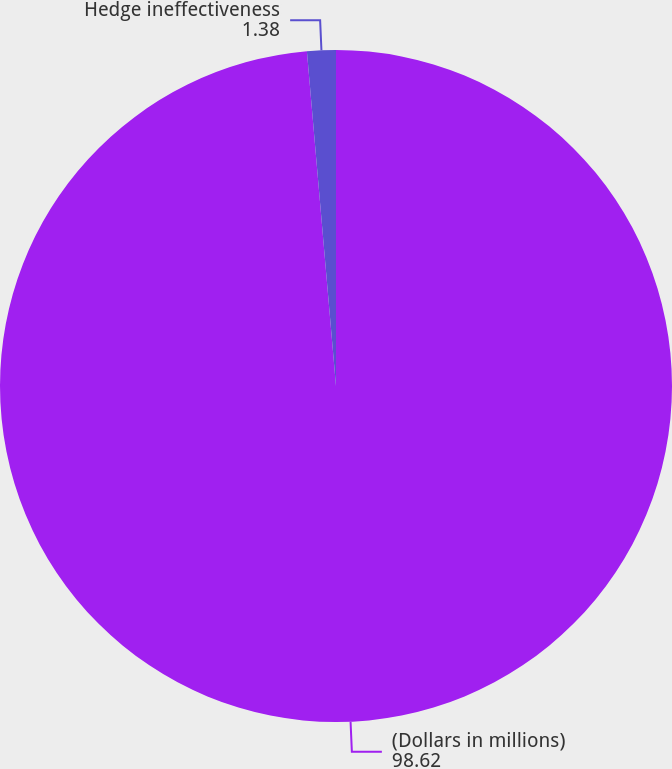<chart> <loc_0><loc_0><loc_500><loc_500><pie_chart><fcel>(Dollars in millions)<fcel>Hedge ineffectiveness<nl><fcel>98.62%<fcel>1.38%<nl></chart> 